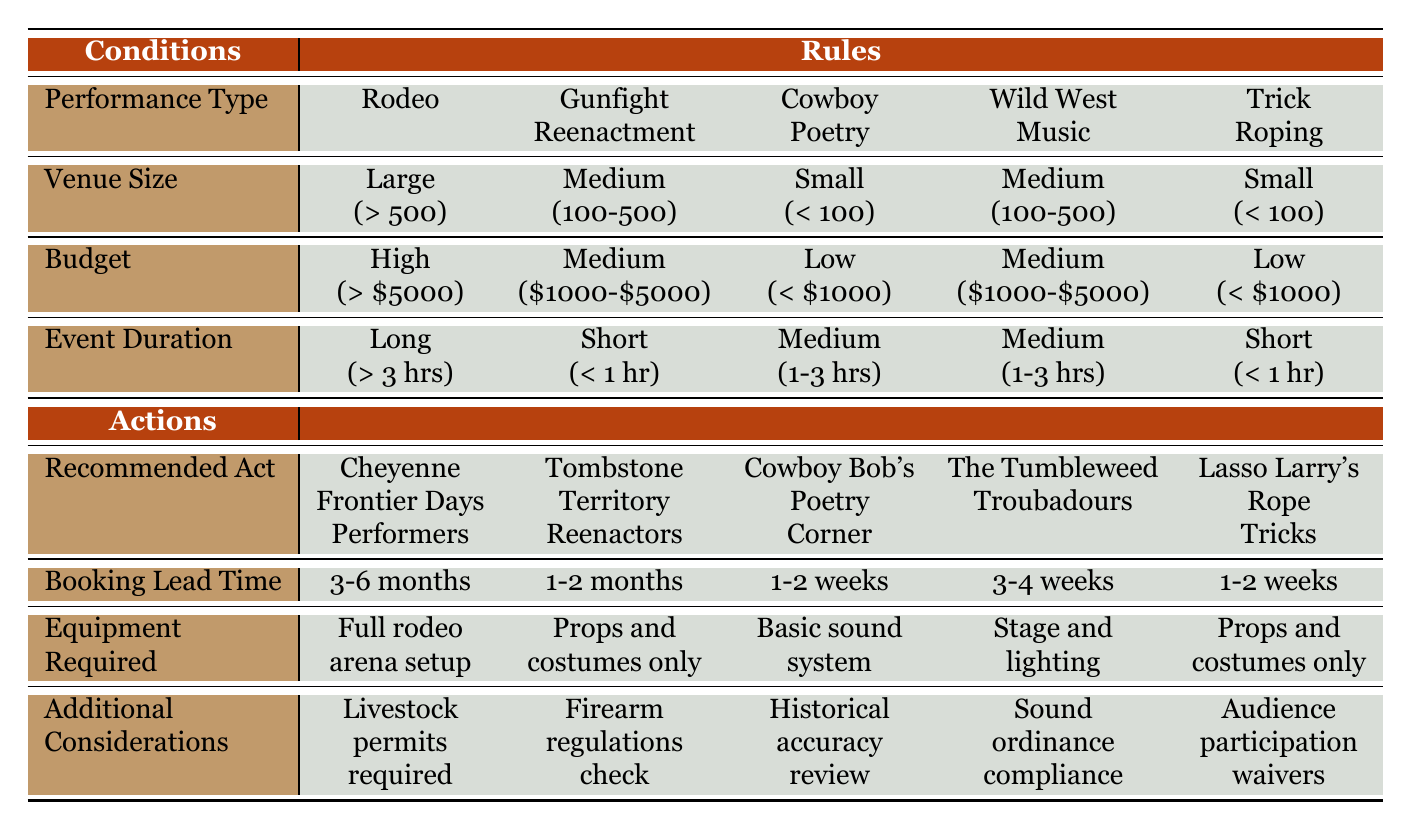What is the recommended act for a rodeo event with a large venue and a high budget? According to the table, the conditions for a rodeo with a large venue (> 500 people) and a high budget (> $5000) point to "Cheyenne Frontier Days Performers" as the recommended act.
Answer: Cheyenne Frontier Days Performers How many weeks in advance should you book a gunfight reenactment for a medium-sized venue? The conditions for a gunfight reenactment in a medium-sized venue (100-500 people) indicate a booking lead time of "1-2 months."
Answer: 1-2 months Is a basic sound system required for a cowboy poetry event? The table shows that for a cowboy poetry event in a small venue with a low budget, the equipment required is a "Basic sound system." Therefore, the answer is yes.
Answer: Yes What are the additional considerations for a trick roping act? For the conditions of a trick roping act in a small venue with a low budget and a short duration, the table indicates that "Audience participation waivers" are the additional consideration required.
Answer: Audience participation waivers If I have a medium-sized venue with a medium budget and want a wild west music performance, what is the required booking lead time? For a wild west music performance in a medium venue (100-500 people) with a medium budget ($1000-$5000), the required booking lead time is "3-4 weeks," as found in the corresponding table row.
Answer: 3-4 weeks 